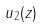Convert formula to latex. <formula><loc_0><loc_0><loc_500><loc_500>u _ { 2 } ( z )</formula> 